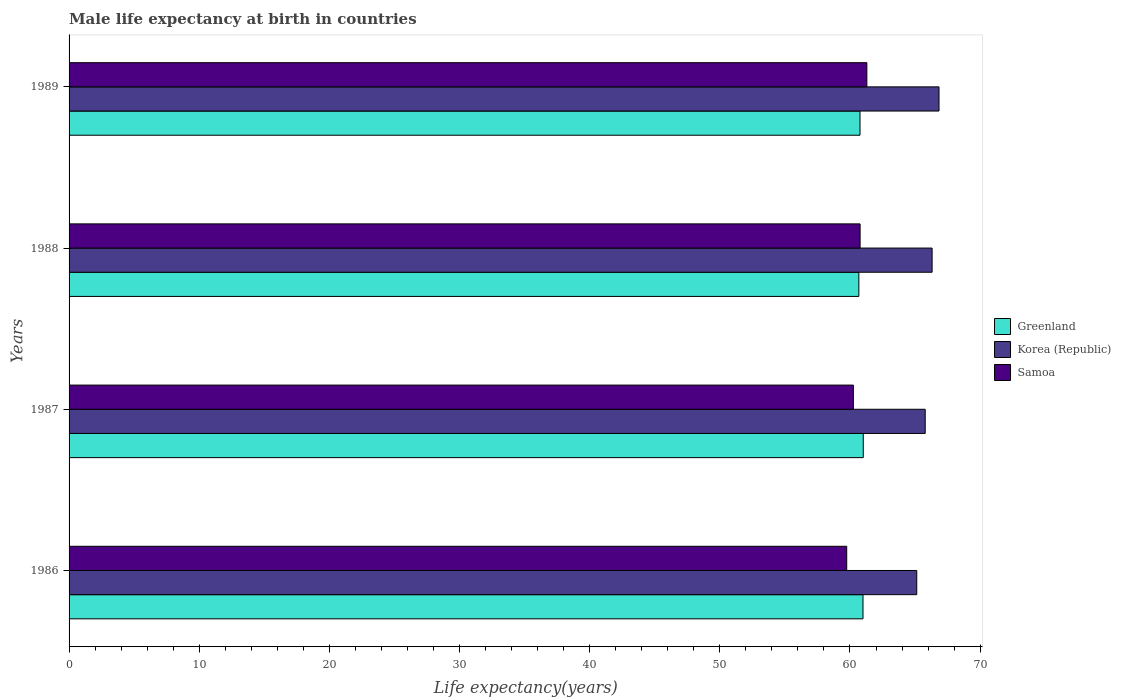What is the male life expectancy at birth in Samoa in 1989?
Provide a short and direct response. 61.3. Across all years, what is the maximum male life expectancy at birth in Korea (Republic)?
Your response must be concise. 66.84. Across all years, what is the minimum male life expectancy at birth in Greenland?
Give a very brief answer. 60.68. In which year was the male life expectancy at birth in Greenland maximum?
Offer a terse response. 1987. What is the total male life expectancy at birth in Korea (Republic) in the graph?
Provide a short and direct response. 264.06. What is the difference between the male life expectancy at birth in Korea (Republic) in 1986 and that in 1988?
Make the answer very short. -1.18. What is the difference between the male life expectancy at birth in Korea (Republic) in 1987 and the male life expectancy at birth in Greenland in 1989?
Provide a short and direct response. 5.01. What is the average male life expectancy at birth in Korea (Republic) per year?
Your response must be concise. 66.02. In the year 1986, what is the difference between the male life expectancy at birth in Korea (Republic) and male life expectancy at birth in Samoa?
Offer a very short reply. 5.38. What is the ratio of the male life expectancy at birth in Greenland in 1987 to that in 1989?
Provide a short and direct response. 1. What is the difference between the highest and the second highest male life expectancy at birth in Korea (Republic)?
Keep it short and to the point. 0.53. What is the difference between the highest and the lowest male life expectancy at birth in Korea (Republic)?
Give a very brief answer. 1.71. In how many years, is the male life expectancy at birth in Greenland greater than the average male life expectancy at birth in Greenland taken over all years?
Your answer should be very brief. 2. Is the sum of the male life expectancy at birth in Greenland in 1988 and 1989 greater than the maximum male life expectancy at birth in Samoa across all years?
Provide a short and direct response. Yes. What does the 3rd bar from the top in 1989 represents?
Make the answer very short. Greenland. What does the 1st bar from the bottom in 1989 represents?
Provide a short and direct response. Greenland. Are all the bars in the graph horizontal?
Your answer should be very brief. Yes. What is the difference between two consecutive major ticks on the X-axis?
Provide a short and direct response. 10. Are the values on the major ticks of X-axis written in scientific E-notation?
Give a very brief answer. No. Does the graph contain grids?
Your answer should be very brief. No. Where does the legend appear in the graph?
Give a very brief answer. Center right. What is the title of the graph?
Your response must be concise. Male life expectancy at birth in countries. Does "Djibouti" appear as one of the legend labels in the graph?
Your response must be concise. No. What is the label or title of the X-axis?
Your answer should be compact. Life expectancy(years). What is the label or title of the Y-axis?
Keep it short and to the point. Years. What is the Life expectancy(years) of Greenland in 1986?
Offer a very short reply. 61. What is the Life expectancy(years) in Korea (Republic) in 1986?
Ensure brevity in your answer.  65.13. What is the Life expectancy(years) of Samoa in 1986?
Provide a short and direct response. 59.75. What is the Life expectancy(years) of Greenland in 1987?
Give a very brief answer. 61.02. What is the Life expectancy(years) in Korea (Republic) in 1987?
Give a very brief answer. 65.78. What is the Life expectancy(years) of Samoa in 1987?
Make the answer very short. 60.26. What is the Life expectancy(years) of Greenland in 1988?
Your response must be concise. 60.68. What is the Life expectancy(years) in Korea (Republic) in 1988?
Keep it short and to the point. 66.31. What is the Life expectancy(years) in Samoa in 1988?
Provide a succinct answer. 60.78. What is the Life expectancy(years) of Greenland in 1989?
Offer a very short reply. 60.77. What is the Life expectancy(years) in Korea (Republic) in 1989?
Your answer should be compact. 66.84. What is the Life expectancy(years) of Samoa in 1989?
Your answer should be compact. 61.3. Across all years, what is the maximum Life expectancy(years) of Greenland?
Give a very brief answer. 61.02. Across all years, what is the maximum Life expectancy(years) in Korea (Republic)?
Keep it short and to the point. 66.84. Across all years, what is the maximum Life expectancy(years) in Samoa?
Make the answer very short. 61.3. Across all years, what is the minimum Life expectancy(years) of Greenland?
Your answer should be very brief. 60.68. Across all years, what is the minimum Life expectancy(years) in Korea (Republic)?
Offer a terse response. 65.13. Across all years, what is the minimum Life expectancy(years) in Samoa?
Keep it short and to the point. 59.75. What is the total Life expectancy(years) of Greenland in the graph?
Ensure brevity in your answer.  243.47. What is the total Life expectancy(years) in Korea (Republic) in the graph?
Give a very brief answer. 264.06. What is the total Life expectancy(years) in Samoa in the graph?
Offer a terse response. 242.08. What is the difference between the Life expectancy(years) in Greenland in 1986 and that in 1987?
Your response must be concise. -0.02. What is the difference between the Life expectancy(years) of Korea (Republic) in 1986 and that in 1987?
Keep it short and to the point. -0.65. What is the difference between the Life expectancy(years) in Samoa in 1986 and that in 1987?
Your answer should be very brief. -0.51. What is the difference between the Life expectancy(years) in Greenland in 1986 and that in 1988?
Provide a short and direct response. 0.32. What is the difference between the Life expectancy(years) in Korea (Republic) in 1986 and that in 1988?
Your answer should be compact. -1.18. What is the difference between the Life expectancy(years) of Samoa in 1986 and that in 1988?
Your response must be concise. -1.03. What is the difference between the Life expectancy(years) in Greenland in 1986 and that in 1989?
Ensure brevity in your answer.  0.23. What is the difference between the Life expectancy(years) of Korea (Republic) in 1986 and that in 1989?
Your answer should be very brief. -1.71. What is the difference between the Life expectancy(years) of Samoa in 1986 and that in 1989?
Your response must be concise. -1.55. What is the difference between the Life expectancy(years) of Greenland in 1987 and that in 1988?
Offer a very short reply. 0.34. What is the difference between the Life expectancy(years) of Korea (Republic) in 1987 and that in 1988?
Make the answer very short. -0.53. What is the difference between the Life expectancy(years) in Samoa in 1987 and that in 1988?
Offer a terse response. -0.52. What is the difference between the Life expectancy(years) of Korea (Republic) in 1987 and that in 1989?
Provide a succinct answer. -1.06. What is the difference between the Life expectancy(years) of Samoa in 1987 and that in 1989?
Keep it short and to the point. -1.04. What is the difference between the Life expectancy(years) of Greenland in 1988 and that in 1989?
Your response must be concise. -0.09. What is the difference between the Life expectancy(years) in Korea (Republic) in 1988 and that in 1989?
Keep it short and to the point. -0.53. What is the difference between the Life expectancy(years) in Samoa in 1988 and that in 1989?
Make the answer very short. -0.52. What is the difference between the Life expectancy(years) of Greenland in 1986 and the Life expectancy(years) of Korea (Republic) in 1987?
Give a very brief answer. -4.78. What is the difference between the Life expectancy(years) of Greenland in 1986 and the Life expectancy(years) of Samoa in 1987?
Keep it short and to the point. 0.74. What is the difference between the Life expectancy(years) of Korea (Republic) in 1986 and the Life expectancy(years) of Samoa in 1987?
Your answer should be very brief. 4.87. What is the difference between the Life expectancy(years) in Greenland in 1986 and the Life expectancy(years) in Korea (Republic) in 1988?
Your answer should be compact. -5.31. What is the difference between the Life expectancy(years) in Greenland in 1986 and the Life expectancy(years) in Samoa in 1988?
Offer a terse response. 0.22. What is the difference between the Life expectancy(years) of Korea (Republic) in 1986 and the Life expectancy(years) of Samoa in 1988?
Give a very brief answer. 4.35. What is the difference between the Life expectancy(years) in Greenland in 1986 and the Life expectancy(years) in Korea (Republic) in 1989?
Ensure brevity in your answer.  -5.84. What is the difference between the Life expectancy(years) of Greenland in 1986 and the Life expectancy(years) of Samoa in 1989?
Give a very brief answer. -0.3. What is the difference between the Life expectancy(years) of Korea (Republic) in 1986 and the Life expectancy(years) of Samoa in 1989?
Your answer should be compact. 3.83. What is the difference between the Life expectancy(years) in Greenland in 1987 and the Life expectancy(years) in Korea (Republic) in 1988?
Your answer should be very brief. -5.29. What is the difference between the Life expectancy(years) of Greenland in 1987 and the Life expectancy(years) of Samoa in 1988?
Provide a succinct answer. 0.24. What is the difference between the Life expectancy(years) of Korea (Republic) in 1987 and the Life expectancy(years) of Samoa in 1988?
Your answer should be compact. 5. What is the difference between the Life expectancy(years) of Greenland in 1987 and the Life expectancy(years) of Korea (Republic) in 1989?
Keep it short and to the point. -5.82. What is the difference between the Life expectancy(years) of Greenland in 1987 and the Life expectancy(years) of Samoa in 1989?
Your answer should be very brief. -0.28. What is the difference between the Life expectancy(years) in Korea (Republic) in 1987 and the Life expectancy(years) in Samoa in 1989?
Provide a short and direct response. 4.48. What is the difference between the Life expectancy(years) in Greenland in 1988 and the Life expectancy(years) in Korea (Republic) in 1989?
Offer a terse response. -6.16. What is the difference between the Life expectancy(years) of Greenland in 1988 and the Life expectancy(years) of Samoa in 1989?
Give a very brief answer. -0.62. What is the difference between the Life expectancy(years) in Korea (Republic) in 1988 and the Life expectancy(years) in Samoa in 1989?
Your answer should be compact. 5.01. What is the average Life expectancy(years) in Greenland per year?
Offer a terse response. 60.87. What is the average Life expectancy(years) of Korea (Republic) per year?
Ensure brevity in your answer.  66.02. What is the average Life expectancy(years) in Samoa per year?
Provide a succinct answer. 60.52. In the year 1986, what is the difference between the Life expectancy(years) of Greenland and Life expectancy(years) of Korea (Republic)?
Your response must be concise. -4.13. In the year 1986, what is the difference between the Life expectancy(years) in Greenland and Life expectancy(years) in Samoa?
Provide a short and direct response. 1.25. In the year 1986, what is the difference between the Life expectancy(years) in Korea (Republic) and Life expectancy(years) in Samoa?
Your answer should be very brief. 5.38. In the year 1987, what is the difference between the Life expectancy(years) of Greenland and Life expectancy(years) of Korea (Republic)?
Your answer should be very brief. -4.76. In the year 1987, what is the difference between the Life expectancy(years) of Greenland and Life expectancy(years) of Samoa?
Ensure brevity in your answer.  0.76. In the year 1987, what is the difference between the Life expectancy(years) in Korea (Republic) and Life expectancy(years) in Samoa?
Ensure brevity in your answer.  5.52. In the year 1988, what is the difference between the Life expectancy(years) of Greenland and Life expectancy(years) of Korea (Republic)?
Offer a terse response. -5.63. In the year 1988, what is the difference between the Life expectancy(years) in Greenland and Life expectancy(years) in Samoa?
Keep it short and to the point. -0.1. In the year 1988, what is the difference between the Life expectancy(years) of Korea (Republic) and Life expectancy(years) of Samoa?
Provide a short and direct response. 5.53. In the year 1989, what is the difference between the Life expectancy(years) of Greenland and Life expectancy(years) of Korea (Republic)?
Provide a short and direct response. -6.07. In the year 1989, what is the difference between the Life expectancy(years) of Greenland and Life expectancy(years) of Samoa?
Your answer should be very brief. -0.53. In the year 1989, what is the difference between the Life expectancy(years) in Korea (Republic) and Life expectancy(years) in Samoa?
Give a very brief answer. 5.54. What is the ratio of the Life expectancy(years) of Greenland in 1986 to that in 1987?
Your response must be concise. 1. What is the ratio of the Life expectancy(years) in Korea (Republic) in 1986 to that in 1988?
Give a very brief answer. 0.98. What is the ratio of the Life expectancy(years) of Samoa in 1986 to that in 1988?
Offer a very short reply. 0.98. What is the ratio of the Life expectancy(years) of Greenland in 1986 to that in 1989?
Your answer should be very brief. 1. What is the ratio of the Life expectancy(years) in Korea (Republic) in 1986 to that in 1989?
Provide a succinct answer. 0.97. What is the ratio of the Life expectancy(years) in Samoa in 1986 to that in 1989?
Provide a short and direct response. 0.97. What is the ratio of the Life expectancy(years) in Greenland in 1987 to that in 1988?
Give a very brief answer. 1.01. What is the ratio of the Life expectancy(years) of Korea (Republic) in 1987 to that in 1988?
Your response must be concise. 0.99. What is the ratio of the Life expectancy(years) in Samoa in 1987 to that in 1988?
Offer a terse response. 0.99. What is the ratio of the Life expectancy(years) of Greenland in 1987 to that in 1989?
Offer a very short reply. 1. What is the ratio of the Life expectancy(years) in Korea (Republic) in 1987 to that in 1989?
Ensure brevity in your answer.  0.98. What is the ratio of the Life expectancy(years) of Samoa in 1987 to that in 1989?
Provide a short and direct response. 0.98. What is the ratio of the Life expectancy(years) of Greenland in 1988 to that in 1989?
Offer a terse response. 1. What is the ratio of the Life expectancy(years) of Samoa in 1988 to that in 1989?
Offer a terse response. 0.99. What is the difference between the highest and the second highest Life expectancy(years) in Greenland?
Provide a short and direct response. 0.02. What is the difference between the highest and the second highest Life expectancy(years) of Korea (Republic)?
Offer a very short reply. 0.53. What is the difference between the highest and the second highest Life expectancy(years) in Samoa?
Offer a terse response. 0.52. What is the difference between the highest and the lowest Life expectancy(years) in Greenland?
Keep it short and to the point. 0.34. What is the difference between the highest and the lowest Life expectancy(years) in Korea (Republic)?
Provide a succinct answer. 1.71. What is the difference between the highest and the lowest Life expectancy(years) of Samoa?
Your answer should be compact. 1.55. 